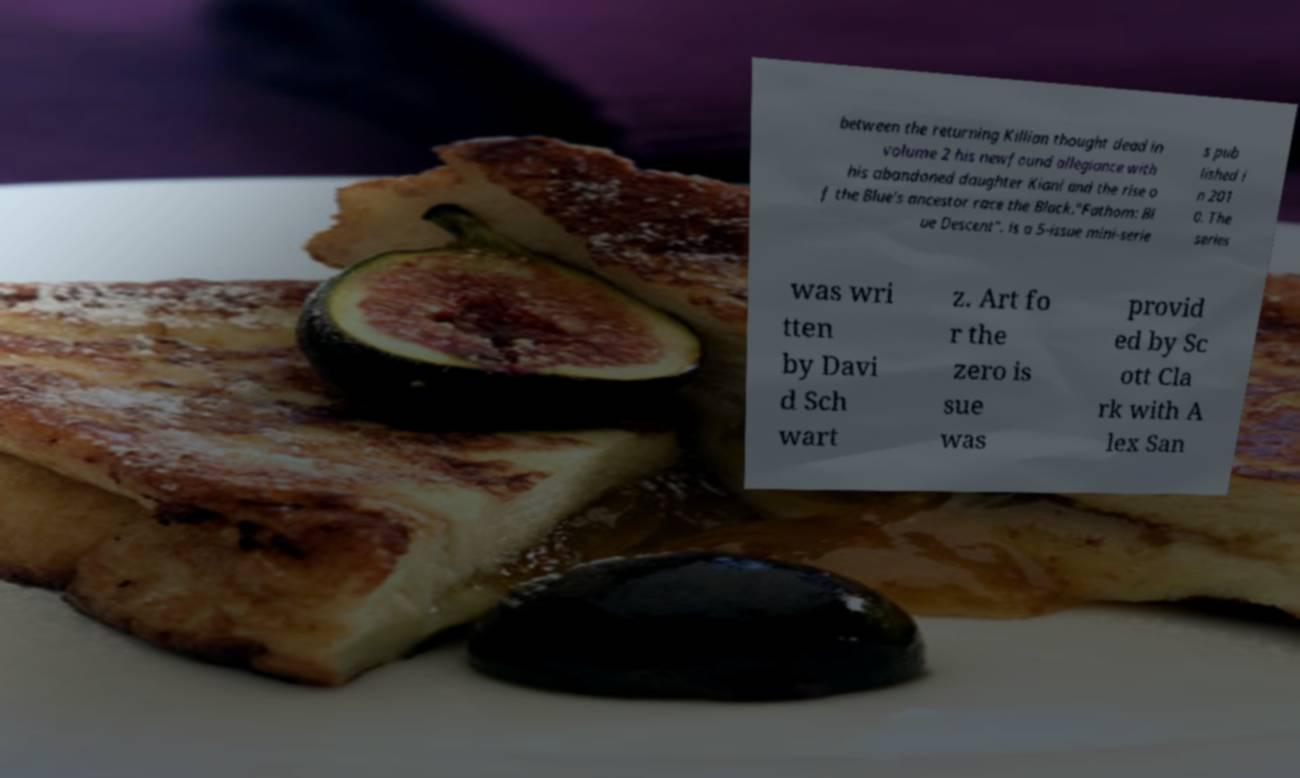Could you assist in decoding the text presented in this image and type it out clearly? between the returning Killian thought dead in volume 2 his newfound allegiance with his abandoned daughter Kiani and the rise o f the Blue's ancestor race the Black."Fathom: Bl ue Descent". is a 5-issue mini-serie s pub lished i n 201 0. The series was wri tten by Davi d Sch wart z. Art fo r the zero is sue was provid ed by Sc ott Cla rk with A lex San 